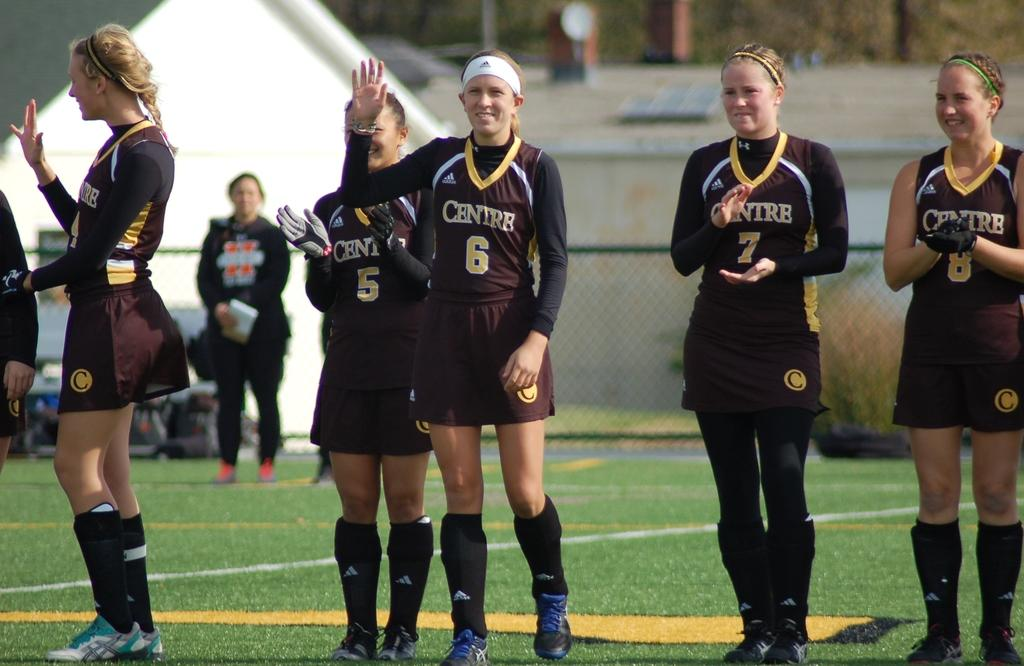Provide a one-sentence caption for the provided image. A girl stand on a field in a black uniform with the number 6 on it. 